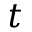Convert formula to latex. <formula><loc_0><loc_0><loc_500><loc_500>t</formula> 